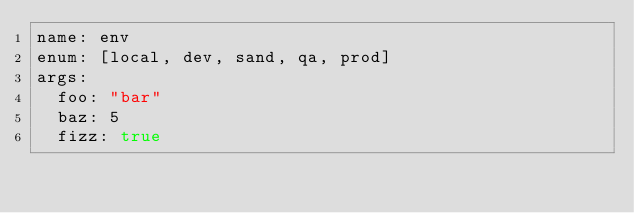<code> <loc_0><loc_0><loc_500><loc_500><_YAML_>name: env
enum: [local, dev, sand, qa, prod]
args:
  foo: "bar"
  baz: 5
  fizz: true</code> 